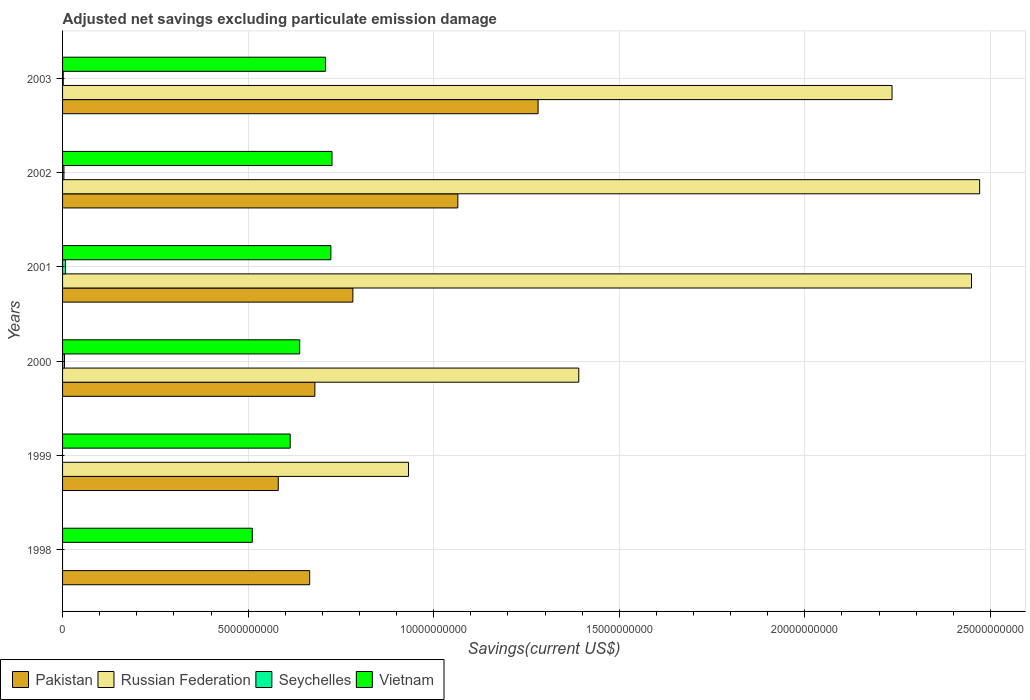How many different coloured bars are there?
Offer a terse response. 4. How many groups of bars are there?
Your answer should be very brief. 6. How many bars are there on the 4th tick from the bottom?
Offer a terse response. 4. In how many cases, is the number of bars for a given year not equal to the number of legend labels?
Ensure brevity in your answer.  2. What is the adjusted net savings in Seychelles in 1998?
Offer a terse response. 0. Across all years, what is the maximum adjusted net savings in Pakistan?
Your answer should be compact. 1.28e+1. Across all years, what is the minimum adjusted net savings in Vietnam?
Make the answer very short. 5.11e+09. In which year was the adjusted net savings in Pakistan maximum?
Provide a succinct answer. 2003. What is the total adjusted net savings in Pakistan in the graph?
Your answer should be compact. 5.06e+1. What is the difference between the adjusted net savings in Pakistan in 1998 and that in 2003?
Give a very brief answer. -6.15e+09. What is the difference between the adjusted net savings in Vietnam in 1999 and the adjusted net savings in Russian Federation in 2001?
Provide a short and direct response. -1.84e+1. What is the average adjusted net savings in Russian Federation per year?
Offer a very short reply. 1.58e+1. In the year 2003, what is the difference between the adjusted net savings in Russian Federation and adjusted net savings in Pakistan?
Keep it short and to the point. 9.54e+09. What is the ratio of the adjusted net savings in Pakistan in 1999 to that in 2002?
Your response must be concise. 0.55. Is the difference between the adjusted net savings in Russian Federation in 1999 and 2002 greater than the difference between the adjusted net savings in Pakistan in 1999 and 2002?
Your response must be concise. No. What is the difference between the highest and the second highest adjusted net savings in Vietnam?
Provide a succinct answer. 3.05e+07. What is the difference between the highest and the lowest adjusted net savings in Russian Federation?
Keep it short and to the point. 2.47e+1. Is it the case that in every year, the sum of the adjusted net savings in Russian Federation and adjusted net savings in Vietnam is greater than the sum of adjusted net savings in Seychelles and adjusted net savings in Pakistan?
Provide a succinct answer. No. Is it the case that in every year, the sum of the adjusted net savings in Pakistan and adjusted net savings in Seychelles is greater than the adjusted net savings in Russian Federation?
Your response must be concise. No. How many bars are there?
Your answer should be compact. 21. How many years are there in the graph?
Give a very brief answer. 6. How many legend labels are there?
Offer a very short reply. 4. How are the legend labels stacked?
Give a very brief answer. Horizontal. What is the title of the graph?
Provide a short and direct response. Adjusted net savings excluding particulate emission damage. Does "Eritrea" appear as one of the legend labels in the graph?
Provide a short and direct response. No. What is the label or title of the X-axis?
Offer a very short reply. Savings(current US$). What is the Savings(current US$) in Pakistan in 1998?
Your answer should be very brief. 6.66e+09. What is the Savings(current US$) of Vietnam in 1998?
Your answer should be very brief. 5.11e+09. What is the Savings(current US$) of Pakistan in 1999?
Your answer should be compact. 5.81e+09. What is the Savings(current US$) of Russian Federation in 1999?
Give a very brief answer. 9.32e+09. What is the Savings(current US$) in Seychelles in 1999?
Offer a very short reply. 0. What is the Savings(current US$) of Vietnam in 1999?
Give a very brief answer. 6.13e+09. What is the Savings(current US$) in Pakistan in 2000?
Offer a terse response. 6.80e+09. What is the Savings(current US$) of Russian Federation in 2000?
Offer a terse response. 1.39e+1. What is the Savings(current US$) of Seychelles in 2000?
Ensure brevity in your answer.  5.11e+07. What is the Savings(current US$) in Vietnam in 2000?
Ensure brevity in your answer.  6.39e+09. What is the Savings(current US$) of Pakistan in 2001?
Keep it short and to the point. 7.82e+09. What is the Savings(current US$) of Russian Federation in 2001?
Make the answer very short. 2.45e+1. What is the Savings(current US$) of Seychelles in 2001?
Ensure brevity in your answer.  8.02e+07. What is the Savings(current US$) of Vietnam in 2001?
Your response must be concise. 7.23e+09. What is the Savings(current US$) in Pakistan in 2002?
Offer a very short reply. 1.07e+1. What is the Savings(current US$) of Russian Federation in 2002?
Your answer should be compact. 2.47e+1. What is the Savings(current US$) of Seychelles in 2002?
Offer a terse response. 3.67e+07. What is the Savings(current US$) in Vietnam in 2002?
Make the answer very short. 7.26e+09. What is the Savings(current US$) of Pakistan in 2003?
Your answer should be compact. 1.28e+1. What is the Savings(current US$) of Russian Federation in 2003?
Offer a terse response. 2.24e+1. What is the Savings(current US$) of Seychelles in 2003?
Keep it short and to the point. 1.83e+07. What is the Savings(current US$) in Vietnam in 2003?
Your response must be concise. 7.09e+09. Across all years, what is the maximum Savings(current US$) in Pakistan?
Your response must be concise. 1.28e+1. Across all years, what is the maximum Savings(current US$) in Russian Federation?
Make the answer very short. 2.47e+1. Across all years, what is the maximum Savings(current US$) in Seychelles?
Your response must be concise. 8.02e+07. Across all years, what is the maximum Savings(current US$) in Vietnam?
Make the answer very short. 7.26e+09. Across all years, what is the minimum Savings(current US$) in Pakistan?
Your response must be concise. 5.81e+09. Across all years, what is the minimum Savings(current US$) in Russian Federation?
Offer a very short reply. 0. Across all years, what is the minimum Savings(current US$) of Vietnam?
Make the answer very short. 5.11e+09. What is the total Savings(current US$) in Pakistan in the graph?
Your answer should be very brief. 5.06e+1. What is the total Savings(current US$) of Russian Federation in the graph?
Your answer should be very brief. 9.48e+1. What is the total Savings(current US$) of Seychelles in the graph?
Your answer should be very brief. 1.86e+08. What is the total Savings(current US$) in Vietnam in the graph?
Provide a short and direct response. 3.92e+1. What is the difference between the Savings(current US$) in Pakistan in 1998 and that in 1999?
Your answer should be compact. 8.47e+08. What is the difference between the Savings(current US$) of Vietnam in 1998 and that in 1999?
Offer a terse response. -1.02e+09. What is the difference between the Savings(current US$) in Pakistan in 1998 and that in 2000?
Your response must be concise. -1.39e+08. What is the difference between the Savings(current US$) of Vietnam in 1998 and that in 2000?
Ensure brevity in your answer.  -1.28e+09. What is the difference between the Savings(current US$) in Pakistan in 1998 and that in 2001?
Your answer should be compact. -1.16e+09. What is the difference between the Savings(current US$) of Vietnam in 1998 and that in 2001?
Your answer should be compact. -2.12e+09. What is the difference between the Savings(current US$) of Pakistan in 1998 and that in 2002?
Provide a succinct answer. -3.99e+09. What is the difference between the Savings(current US$) in Vietnam in 1998 and that in 2002?
Provide a short and direct response. -2.15e+09. What is the difference between the Savings(current US$) in Pakistan in 1998 and that in 2003?
Your response must be concise. -6.15e+09. What is the difference between the Savings(current US$) in Vietnam in 1998 and that in 2003?
Make the answer very short. -1.97e+09. What is the difference between the Savings(current US$) of Pakistan in 1999 and that in 2000?
Ensure brevity in your answer.  -9.86e+08. What is the difference between the Savings(current US$) of Russian Federation in 1999 and that in 2000?
Make the answer very short. -4.59e+09. What is the difference between the Savings(current US$) in Vietnam in 1999 and that in 2000?
Keep it short and to the point. -2.56e+08. What is the difference between the Savings(current US$) in Pakistan in 1999 and that in 2001?
Make the answer very short. -2.01e+09. What is the difference between the Savings(current US$) in Russian Federation in 1999 and that in 2001?
Give a very brief answer. -1.52e+1. What is the difference between the Savings(current US$) in Vietnam in 1999 and that in 2001?
Make the answer very short. -1.10e+09. What is the difference between the Savings(current US$) in Pakistan in 1999 and that in 2002?
Provide a short and direct response. -4.84e+09. What is the difference between the Savings(current US$) of Russian Federation in 1999 and that in 2002?
Make the answer very short. -1.54e+1. What is the difference between the Savings(current US$) of Vietnam in 1999 and that in 2002?
Your answer should be very brief. -1.13e+09. What is the difference between the Savings(current US$) of Pakistan in 1999 and that in 2003?
Keep it short and to the point. -7.00e+09. What is the difference between the Savings(current US$) of Russian Federation in 1999 and that in 2003?
Your answer should be compact. -1.30e+1. What is the difference between the Savings(current US$) of Vietnam in 1999 and that in 2003?
Your response must be concise. -9.53e+08. What is the difference between the Savings(current US$) in Pakistan in 2000 and that in 2001?
Ensure brevity in your answer.  -1.02e+09. What is the difference between the Savings(current US$) of Russian Federation in 2000 and that in 2001?
Ensure brevity in your answer.  -1.06e+1. What is the difference between the Savings(current US$) in Seychelles in 2000 and that in 2001?
Your response must be concise. -2.90e+07. What is the difference between the Savings(current US$) in Vietnam in 2000 and that in 2001?
Make the answer very short. -8.40e+08. What is the difference between the Savings(current US$) of Pakistan in 2000 and that in 2002?
Give a very brief answer. -3.85e+09. What is the difference between the Savings(current US$) of Russian Federation in 2000 and that in 2002?
Give a very brief answer. -1.08e+1. What is the difference between the Savings(current US$) of Seychelles in 2000 and that in 2002?
Provide a succinct answer. 1.44e+07. What is the difference between the Savings(current US$) in Vietnam in 2000 and that in 2002?
Your response must be concise. -8.70e+08. What is the difference between the Savings(current US$) of Pakistan in 2000 and that in 2003?
Provide a succinct answer. -6.02e+09. What is the difference between the Savings(current US$) in Russian Federation in 2000 and that in 2003?
Your answer should be very brief. -8.44e+09. What is the difference between the Savings(current US$) in Seychelles in 2000 and that in 2003?
Your answer should be very brief. 3.28e+07. What is the difference between the Savings(current US$) in Vietnam in 2000 and that in 2003?
Your response must be concise. -6.97e+08. What is the difference between the Savings(current US$) in Pakistan in 2001 and that in 2002?
Offer a terse response. -2.83e+09. What is the difference between the Savings(current US$) of Russian Federation in 2001 and that in 2002?
Your answer should be very brief. -2.19e+08. What is the difference between the Savings(current US$) in Seychelles in 2001 and that in 2002?
Offer a terse response. 4.35e+07. What is the difference between the Savings(current US$) of Vietnam in 2001 and that in 2002?
Your answer should be compact. -3.05e+07. What is the difference between the Savings(current US$) of Pakistan in 2001 and that in 2003?
Your answer should be compact. -4.99e+09. What is the difference between the Savings(current US$) of Russian Federation in 2001 and that in 2003?
Make the answer very short. 2.14e+09. What is the difference between the Savings(current US$) in Seychelles in 2001 and that in 2003?
Keep it short and to the point. 6.18e+07. What is the difference between the Savings(current US$) in Vietnam in 2001 and that in 2003?
Give a very brief answer. 1.43e+08. What is the difference between the Savings(current US$) in Pakistan in 2002 and that in 2003?
Provide a short and direct response. -2.16e+09. What is the difference between the Savings(current US$) in Russian Federation in 2002 and that in 2003?
Offer a very short reply. 2.36e+09. What is the difference between the Savings(current US$) in Seychelles in 2002 and that in 2003?
Your answer should be very brief. 1.84e+07. What is the difference between the Savings(current US$) in Vietnam in 2002 and that in 2003?
Give a very brief answer. 1.73e+08. What is the difference between the Savings(current US$) of Pakistan in 1998 and the Savings(current US$) of Russian Federation in 1999?
Make the answer very short. -2.66e+09. What is the difference between the Savings(current US$) of Pakistan in 1998 and the Savings(current US$) of Vietnam in 1999?
Provide a succinct answer. 5.25e+08. What is the difference between the Savings(current US$) in Pakistan in 1998 and the Savings(current US$) in Russian Federation in 2000?
Give a very brief answer. -7.25e+09. What is the difference between the Savings(current US$) of Pakistan in 1998 and the Savings(current US$) of Seychelles in 2000?
Ensure brevity in your answer.  6.61e+09. What is the difference between the Savings(current US$) of Pakistan in 1998 and the Savings(current US$) of Vietnam in 2000?
Keep it short and to the point. 2.69e+08. What is the difference between the Savings(current US$) in Pakistan in 1998 and the Savings(current US$) in Russian Federation in 2001?
Provide a succinct answer. -1.78e+1. What is the difference between the Savings(current US$) of Pakistan in 1998 and the Savings(current US$) of Seychelles in 2001?
Offer a terse response. 6.58e+09. What is the difference between the Savings(current US$) of Pakistan in 1998 and the Savings(current US$) of Vietnam in 2001?
Offer a very short reply. -5.71e+08. What is the difference between the Savings(current US$) in Pakistan in 1998 and the Savings(current US$) in Russian Federation in 2002?
Give a very brief answer. -1.81e+1. What is the difference between the Savings(current US$) in Pakistan in 1998 and the Savings(current US$) in Seychelles in 2002?
Provide a succinct answer. 6.62e+09. What is the difference between the Savings(current US$) in Pakistan in 1998 and the Savings(current US$) in Vietnam in 2002?
Provide a short and direct response. -6.01e+08. What is the difference between the Savings(current US$) in Pakistan in 1998 and the Savings(current US$) in Russian Federation in 2003?
Ensure brevity in your answer.  -1.57e+1. What is the difference between the Savings(current US$) of Pakistan in 1998 and the Savings(current US$) of Seychelles in 2003?
Provide a short and direct response. 6.64e+09. What is the difference between the Savings(current US$) of Pakistan in 1998 and the Savings(current US$) of Vietnam in 2003?
Ensure brevity in your answer.  -4.28e+08. What is the difference between the Savings(current US$) of Pakistan in 1999 and the Savings(current US$) of Russian Federation in 2000?
Your answer should be very brief. -8.10e+09. What is the difference between the Savings(current US$) of Pakistan in 1999 and the Savings(current US$) of Seychelles in 2000?
Give a very brief answer. 5.76e+09. What is the difference between the Savings(current US$) of Pakistan in 1999 and the Savings(current US$) of Vietnam in 2000?
Your answer should be very brief. -5.78e+08. What is the difference between the Savings(current US$) of Russian Federation in 1999 and the Savings(current US$) of Seychelles in 2000?
Your answer should be very brief. 9.27e+09. What is the difference between the Savings(current US$) of Russian Federation in 1999 and the Savings(current US$) of Vietnam in 2000?
Your response must be concise. 2.93e+09. What is the difference between the Savings(current US$) of Pakistan in 1999 and the Savings(current US$) of Russian Federation in 2001?
Ensure brevity in your answer.  -1.87e+1. What is the difference between the Savings(current US$) in Pakistan in 1999 and the Savings(current US$) in Seychelles in 2001?
Keep it short and to the point. 5.73e+09. What is the difference between the Savings(current US$) of Pakistan in 1999 and the Savings(current US$) of Vietnam in 2001?
Provide a succinct answer. -1.42e+09. What is the difference between the Savings(current US$) in Russian Federation in 1999 and the Savings(current US$) in Seychelles in 2001?
Ensure brevity in your answer.  9.24e+09. What is the difference between the Savings(current US$) of Russian Federation in 1999 and the Savings(current US$) of Vietnam in 2001?
Your response must be concise. 2.09e+09. What is the difference between the Savings(current US$) of Pakistan in 1999 and the Savings(current US$) of Russian Federation in 2002?
Offer a terse response. -1.89e+1. What is the difference between the Savings(current US$) in Pakistan in 1999 and the Savings(current US$) in Seychelles in 2002?
Give a very brief answer. 5.78e+09. What is the difference between the Savings(current US$) in Pakistan in 1999 and the Savings(current US$) in Vietnam in 2002?
Give a very brief answer. -1.45e+09. What is the difference between the Savings(current US$) of Russian Federation in 1999 and the Savings(current US$) of Seychelles in 2002?
Keep it short and to the point. 9.29e+09. What is the difference between the Savings(current US$) of Russian Federation in 1999 and the Savings(current US$) of Vietnam in 2002?
Ensure brevity in your answer.  2.06e+09. What is the difference between the Savings(current US$) in Pakistan in 1999 and the Savings(current US$) in Russian Federation in 2003?
Keep it short and to the point. -1.65e+1. What is the difference between the Savings(current US$) in Pakistan in 1999 and the Savings(current US$) in Seychelles in 2003?
Ensure brevity in your answer.  5.79e+09. What is the difference between the Savings(current US$) in Pakistan in 1999 and the Savings(current US$) in Vietnam in 2003?
Offer a very short reply. -1.27e+09. What is the difference between the Savings(current US$) of Russian Federation in 1999 and the Savings(current US$) of Seychelles in 2003?
Keep it short and to the point. 9.30e+09. What is the difference between the Savings(current US$) of Russian Federation in 1999 and the Savings(current US$) of Vietnam in 2003?
Offer a very short reply. 2.24e+09. What is the difference between the Savings(current US$) in Pakistan in 2000 and the Savings(current US$) in Russian Federation in 2001?
Provide a short and direct response. -1.77e+1. What is the difference between the Savings(current US$) in Pakistan in 2000 and the Savings(current US$) in Seychelles in 2001?
Provide a short and direct response. 6.72e+09. What is the difference between the Savings(current US$) of Pakistan in 2000 and the Savings(current US$) of Vietnam in 2001?
Keep it short and to the point. -4.32e+08. What is the difference between the Savings(current US$) in Russian Federation in 2000 and the Savings(current US$) in Seychelles in 2001?
Your response must be concise. 1.38e+1. What is the difference between the Savings(current US$) of Russian Federation in 2000 and the Savings(current US$) of Vietnam in 2001?
Provide a short and direct response. 6.68e+09. What is the difference between the Savings(current US$) in Seychelles in 2000 and the Savings(current US$) in Vietnam in 2001?
Provide a succinct answer. -7.18e+09. What is the difference between the Savings(current US$) in Pakistan in 2000 and the Savings(current US$) in Russian Federation in 2002?
Make the answer very short. -1.79e+1. What is the difference between the Savings(current US$) in Pakistan in 2000 and the Savings(current US$) in Seychelles in 2002?
Offer a very short reply. 6.76e+09. What is the difference between the Savings(current US$) of Pakistan in 2000 and the Savings(current US$) of Vietnam in 2002?
Your response must be concise. -4.62e+08. What is the difference between the Savings(current US$) of Russian Federation in 2000 and the Savings(current US$) of Seychelles in 2002?
Provide a succinct answer. 1.39e+1. What is the difference between the Savings(current US$) in Russian Federation in 2000 and the Savings(current US$) in Vietnam in 2002?
Ensure brevity in your answer.  6.65e+09. What is the difference between the Savings(current US$) of Seychelles in 2000 and the Savings(current US$) of Vietnam in 2002?
Your answer should be very brief. -7.21e+09. What is the difference between the Savings(current US$) of Pakistan in 2000 and the Savings(current US$) of Russian Federation in 2003?
Provide a short and direct response. -1.56e+1. What is the difference between the Savings(current US$) of Pakistan in 2000 and the Savings(current US$) of Seychelles in 2003?
Keep it short and to the point. 6.78e+09. What is the difference between the Savings(current US$) in Pakistan in 2000 and the Savings(current US$) in Vietnam in 2003?
Your answer should be compact. -2.88e+08. What is the difference between the Savings(current US$) of Russian Federation in 2000 and the Savings(current US$) of Seychelles in 2003?
Your response must be concise. 1.39e+1. What is the difference between the Savings(current US$) of Russian Federation in 2000 and the Savings(current US$) of Vietnam in 2003?
Your answer should be very brief. 6.82e+09. What is the difference between the Savings(current US$) in Seychelles in 2000 and the Savings(current US$) in Vietnam in 2003?
Your answer should be compact. -7.04e+09. What is the difference between the Savings(current US$) of Pakistan in 2001 and the Savings(current US$) of Russian Federation in 2002?
Provide a succinct answer. -1.69e+1. What is the difference between the Savings(current US$) in Pakistan in 2001 and the Savings(current US$) in Seychelles in 2002?
Provide a short and direct response. 7.79e+09. What is the difference between the Savings(current US$) in Pakistan in 2001 and the Savings(current US$) in Vietnam in 2002?
Your answer should be very brief. 5.63e+08. What is the difference between the Savings(current US$) of Russian Federation in 2001 and the Savings(current US$) of Seychelles in 2002?
Provide a short and direct response. 2.45e+1. What is the difference between the Savings(current US$) of Russian Federation in 2001 and the Savings(current US$) of Vietnam in 2002?
Give a very brief answer. 1.72e+1. What is the difference between the Savings(current US$) in Seychelles in 2001 and the Savings(current US$) in Vietnam in 2002?
Provide a short and direct response. -7.18e+09. What is the difference between the Savings(current US$) of Pakistan in 2001 and the Savings(current US$) of Russian Federation in 2003?
Your answer should be very brief. -1.45e+1. What is the difference between the Savings(current US$) in Pakistan in 2001 and the Savings(current US$) in Seychelles in 2003?
Offer a very short reply. 7.80e+09. What is the difference between the Savings(current US$) in Pakistan in 2001 and the Savings(current US$) in Vietnam in 2003?
Your answer should be very brief. 7.36e+08. What is the difference between the Savings(current US$) of Russian Federation in 2001 and the Savings(current US$) of Seychelles in 2003?
Keep it short and to the point. 2.45e+1. What is the difference between the Savings(current US$) of Russian Federation in 2001 and the Savings(current US$) of Vietnam in 2003?
Make the answer very short. 1.74e+1. What is the difference between the Savings(current US$) in Seychelles in 2001 and the Savings(current US$) in Vietnam in 2003?
Offer a very short reply. -7.01e+09. What is the difference between the Savings(current US$) of Pakistan in 2002 and the Savings(current US$) of Russian Federation in 2003?
Give a very brief answer. -1.17e+1. What is the difference between the Savings(current US$) of Pakistan in 2002 and the Savings(current US$) of Seychelles in 2003?
Keep it short and to the point. 1.06e+1. What is the difference between the Savings(current US$) in Pakistan in 2002 and the Savings(current US$) in Vietnam in 2003?
Keep it short and to the point. 3.56e+09. What is the difference between the Savings(current US$) of Russian Federation in 2002 and the Savings(current US$) of Seychelles in 2003?
Make the answer very short. 2.47e+1. What is the difference between the Savings(current US$) in Russian Federation in 2002 and the Savings(current US$) in Vietnam in 2003?
Keep it short and to the point. 1.76e+1. What is the difference between the Savings(current US$) in Seychelles in 2002 and the Savings(current US$) in Vietnam in 2003?
Give a very brief answer. -7.05e+09. What is the average Savings(current US$) in Pakistan per year?
Ensure brevity in your answer.  8.43e+09. What is the average Savings(current US$) in Russian Federation per year?
Offer a terse response. 1.58e+1. What is the average Savings(current US$) of Seychelles per year?
Your answer should be very brief. 3.10e+07. What is the average Savings(current US$) of Vietnam per year?
Your answer should be compact. 6.54e+09. In the year 1998, what is the difference between the Savings(current US$) in Pakistan and Savings(current US$) in Vietnam?
Your answer should be very brief. 1.55e+09. In the year 1999, what is the difference between the Savings(current US$) of Pakistan and Savings(current US$) of Russian Federation?
Make the answer very short. -3.51e+09. In the year 1999, what is the difference between the Savings(current US$) of Pakistan and Savings(current US$) of Vietnam?
Your answer should be very brief. -3.21e+08. In the year 1999, what is the difference between the Savings(current US$) in Russian Federation and Savings(current US$) in Vietnam?
Provide a short and direct response. 3.19e+09. In the year 2000, what is the difference between the Savings(current US$) in Pakistan and Savings(current US$) in Russian Federation?
Provide a succinct answer. -7.11e+09. In the year 2000, what is the difference between the Savings(current US$) of Pakistan and Savings(current US$) of Seychelles?
Offer a very short reply. 6.75e+09. In the year 2000, what is the difference between the Savings(current US$) in Pakistan and Savings(current US$) in Vietnam?
Keep it short and to the point. 4.08e+08. In the year 2000, what is the difference between the Savings(current US$) of Russian Federation and Savings(current US$) of Seychelles?
Make the answer very short. 1.39e+1. In the year 2000, what is the difference between the Savings(current US$) of Russian Federation and Savings(current US$) of Vietnam?
Offer a terse response. 7.52e+09. In the year 2000, what is the difference between the Savings(current US$) in Seychelles and Savings(current US$) in Vietnam?
Offer a terse response. -6.34e+09. In the year 2001, what is the difference between the Savings(current US$) in Pakistan and Savings(current US$) in Russian Federation?
Keep it short and to the point. -1.67e+1. In the year 2001, what is the difference between the Savings(current US$) in Pakistan and Savings(current US$) in Seychelles?
Give a very brief answer. 7.74e+09. In the year 2001, what is the difference between the Savings(current US$) in Pakistan and Savings(current US$) in Vietnam?
Provide a short and direct response. 5.93e+08. In the year 2001, what is the difference between the Savings(current US$) in Russian Federation and Savings(current US$) in Seychelles?
Provide a short and direct response. 2.44e+1. In the year 2001, what is the difference between the Savings(current US$) in Russian Federation and Savings(current US$) in Vietnam?
Make the answer very short. 1.73e+1. In the year 2001, what is the difference between the Savings(current US$) of Seychelles and Savings(current US$) of Vietnam?
Offer a very short reply. -7.15e+09. In the year 2002, what is the difference between the Savings(current US$) of Pakistan and Savings(current US$) of Russian Federation?
Offer a terse response. -1.41e+1. In the year 2002, what is the difference between the Savings(current US$) of Pakistan and Savings(current US$) of Seychelles?
Offer a very short reply. 1.06e+1. In the year 2002, what is the difference between the Savings(current US$) in Pakistan and Savings(current US$) in Vietnam?
Give a very brief answer. 3.39e+09. In the year 2002, what is the difference between the Savings(current US$) of Russian Federation and Savings(current US$) of Seychelles?
Ensure brevity in your answer.  2.47e+1. In the year 2002, what is the difference between the Savings(current US$) in Russian Federation and Savings(current US$) in Vietnam?
Provide a short and direct response. 1.75e+1. In the year 2002, what is the difference between the Savings(current US$) of Seychelles and Savings(current US$) of Vietnam?
Offer a very short reply. -7.22e+09. In the year 2003, what is the difference between the Savings(current US$) of Pakistan and Savings(current US$) of Russian Federation?
Give a very brief answer. -9.54e+09. In the year 2003, what is the difference between the Savings(current US$) of Pakistan and Savings(current US$) of Seychelles?
Offer a very short reply. 1.28e+1. In the year 2003, what is the difference between the Savings(current US$) of Pakistan and Savings(current US$) of Vietnam?
Your response must be concise. 5.73e+09. In the year 2003, what is the difference between the Savings(current US$) in Russian Federation and Savings(current US$) in Seychelles?
Provide a short and direct response. 2.23e+1. In the year 2003, what is the difference between the Savings(current US$) of Russian Federation and Savings(current US$) of Vietnam?
Ensure brevity in your answer.  1.53e+1. In the year 2003, what is the difference between the Savings(current US$) of Seychelles and Savings(current US$) of Vietnam?
Give a very brief answer. -7.07e+09. What is the ratio of the Savings(current US$) in Pakistan in 1998 to that in 1999?
Offer a very short reply. 1.15. What is the ratio of the Savings(current US$) of Vietnam in 1998 to that in 1999?
Make the answer very short. 0.83. What is the ratio of the Savings(current US$) of Pakistan in 1998 to that in 2000?
Your answer should be compact. 0.98. What is the ratio of the Savings(current US$) of Pakistan in 1998 to that in 2001?
Offer a terse response. 0.85. What is the ratio of the Savings(current US$) in Vietnam in 1998 to that in 2001?
Provide a succinct answer. 0.71. What is the ratio of the Savings(current US$) of Pakistan in 1998 to that in 2002?
Offer a very short reply. 0.63. What is the ratio of the Savings(current US$) in Vietnam in 1998 to that in 2002?
Make the answer very short. 0.7. What is the ratio of the Savings(current US$) in Pakistan in 1998 to that in 2003?
Make the answer very short. 0.52. What is the ratio of the Savings(current US$) of Vietnam in 1998 to that in 2003?
Keep it short and to the point. 0.72. What is the ratio of the Savings(current US$) of Pakistan in 1999 to that in 2000?
Your answer should be very brief. 0.85. What is the ratio of the Savings(current US$) in Russian Federation in 1999 to that in 2000?
Give a very brief answer. 0.67. What is the ratio of the Savings(current US$) of Vietnam in 1999 to that in 2000?
Offer a terse response. 0.96. What is the ratio of the Savings(current US$) of Pakistan in 1999 to that in 2001?
Provide a short and direct response. 0.74. What is the ratio of the Savings(current US$) in Russian Federation in 1999 to that in 2001?
Your answer should be compact. 0.38. What is the ratio of the Savings(current US$) of Vietnam in 1999 to that in 2001?
Give a very brief answer. 0.85. What is the ratio of the Savings(current US$) in Pakistan in 1999 to that in 2002?
Give a very brief answer. 0.55. What is the ratio of the Savings(current US$) of Russian Federation in 1999 to that in 2002?
Your response must be concise. 0.38. What is the ratio of the Savings(current US$) in Vietnam in 1999 to that in 2002?
Your response must be concise. 0.84. What is the ratio of the Savings(current US$) of Pakistan in 1999 to that in 2003?
Keep it short and to the point. 0.45. What is the ratio of the Savings(current US$) of Russian Federation in 1999 to that in 2003?
Offer a very short reply. 0.42. What is the ratio of the Savings(current US$) in Vietnam in 1999 to that in 2003?
Offer a terse response. 0.87. What is the ratio of the Savings(current US$) of Pakistan in 2000 to that in 2001?
Your answer should be very brief. 0.87. What is the ratio of the Savings(current US$) in Russian Federation in 2000 to that in 2001?
Your answer should be compact. 0.57. What is the ratio of the Savings(current US$) in Seychelles in 2000 to that in 2001?
Offer a terse response. 0.64. What is the ratio of the Savings(current US$) in Vietnam in 2000 to that in 2001?
Your answer should be compact. 0.88. What is the ratio of the Savings(current US$) of Pakistan in 2000 to that in 2002?
Keep it short and to the point. 0.64. What is the ratio of the Savings(current US$) of Russian Federation in 2000 to that in 2002?
Make the answer very short. 0.56. What is the ratio of the Savings(current US$) of Seychelles in 2000 to that in 2002?
Provide a succinct answer. 1.39. What is the ratio of the Savings(current US$) in Vietnam in 2000 to that in 2002?
Ensure brevity in your answer.  0.88. What is the ratio of the Savings(current US$) of Pakistan in 2000 to that in 2003?
Ensure brevity in your answer.  0.53. What is the ratio of the Savings(current US$) in Russian Federation in 2000 to that in 2003?
Offer a very short reply. 0.62. What is the ratio of the Savings(current US$) of Seychelles in 2000 to that in 2003?
Keep it short and to the point. 2.79. What is the ratio of the Savings(current US$) in Vietnam in 2000 to that in 2003?
Keep it short and to the point. 0.9. What is the ratio of the Savings(current US$) of Pakistan in 2001 to that in 2002?
Your answer should be compact. 0.73. What is the ratio of the Savings(current US$) in Russian Federation in 2001 to that in 2002?
Provide a succinct answer. 0.99. What is the ratio of the Savings(current US$) in Seychelles in 2001 to that in 2002?
Your answer should be very brief. 2.19. What is the ratio of the Savings(current US$) of Pakistan in 2001 to that in 2003?
Make the answer very short. 0.61. What is the ratio of the Savings(current US$) in Russian Federation in 2001 to that in 2003?
Ensure brevity in your answer.  1.1. What is the ratio of the Savings(current US$) in Seychelles in 2001 to that in 2003?
Your answer should be compact. 4.37. What is the ratio of the Savings(current US$) of Vietnam in 2001 to that in 2003?
Offer a terse response. 1.02. What is the ratio of the Savings(current US$) of Pakistan in 2002 to that in 2003?
Your answer should be compact. 0.83. What is the ratio of the Savings(current US$) of Russian Federation in 2002 to that in 2003?
Your response must be concise. 1.11. What is the ratio of the Savings(current US$) in Seychelles in 2002 to that in 2003?
Your answer should be very brief. 2. What is the ratio of the Savings(current US$) in Vietnam in 2002 to that in 2003?
Your answer should be compact. 1.02. What is the difference between the highest and the second highest Savings(current US$) of Pakistan?
Your answer should be compact. 2.16e+09. What is the difference between the highest and the second highest Savings(current US$) of Russian Federation?
Give a very brief answer. 2.19e+08. What is the difference between the highest and the second highest Savings(current US$) of Seychelles?
Your answer should be very brief. 2.90e+07. What is the difference between the highest and the second highest Savings(current US$) of Vietnam?
Your response must be concise. 3.05e+07. What is the difference between the highest and the lowest Savings(current US$) of Pakistan?
Keep it short and to the point. 7.00e+09. What is the difference between the highest and the lowest Savings(current US$) in Russian Federation?
Your response must be concise. 2.47e+1. What is the difference between the highest and the lowest Savings(current US$) in Seychelles?
Make the answer very short. 8.02e+07. What is the difference between the highest and the lowest Savings(current US$) of Vietnam?
Give a very brief answer. 2.15e+09. 